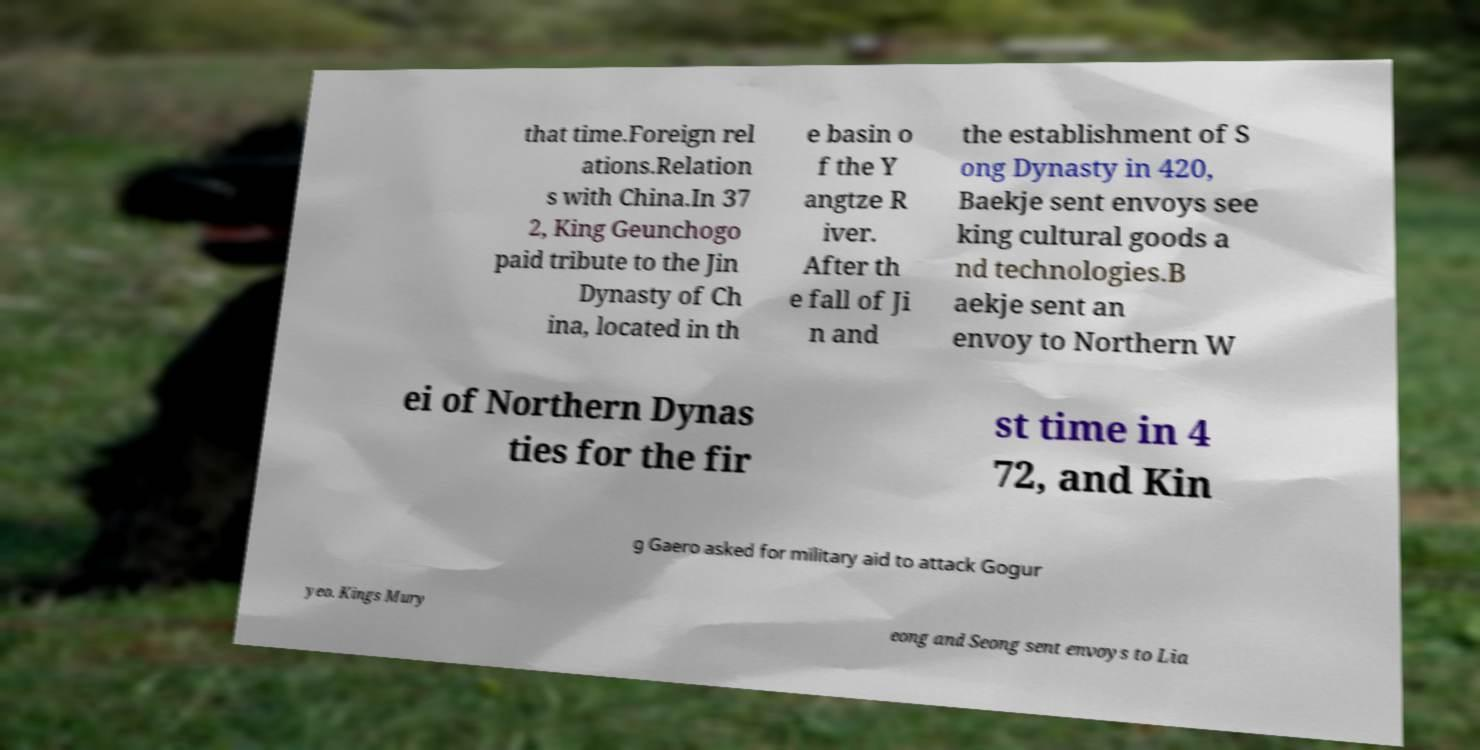Could you extract and type out the text from this image? that time.Foreign rel ations.Relation s with China.In 37 2, King Geunchogo paid tribute to the Jin Dynasty of Ch ina, located in th e basin o f the Y angtze R iver. After th e fall of Ji n and the establishment of S ong Dynasty in 420, Baekje sent envoys see king cultural goods a nd technologies.B aekje sent an envoy to Northern W ei of Northern Dynas ties for the fir st time in 4 72, and Kin g Gaero asked for military aid to attack Gogur yeo. Kings Mury eong and Seong sent envoys to Lia 